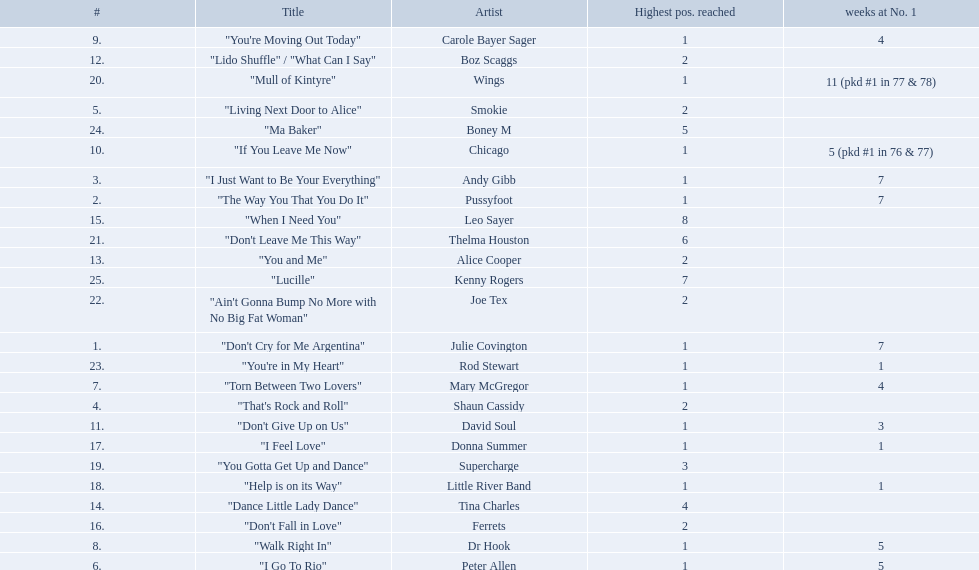How long is the longest amount of time spent at number 1? 11 (pkd #1 in 77 & 78). What song spent 11 weeks at number 1? "Mull of Kintyre". What band had a number 1 hit with this song? Wings. 